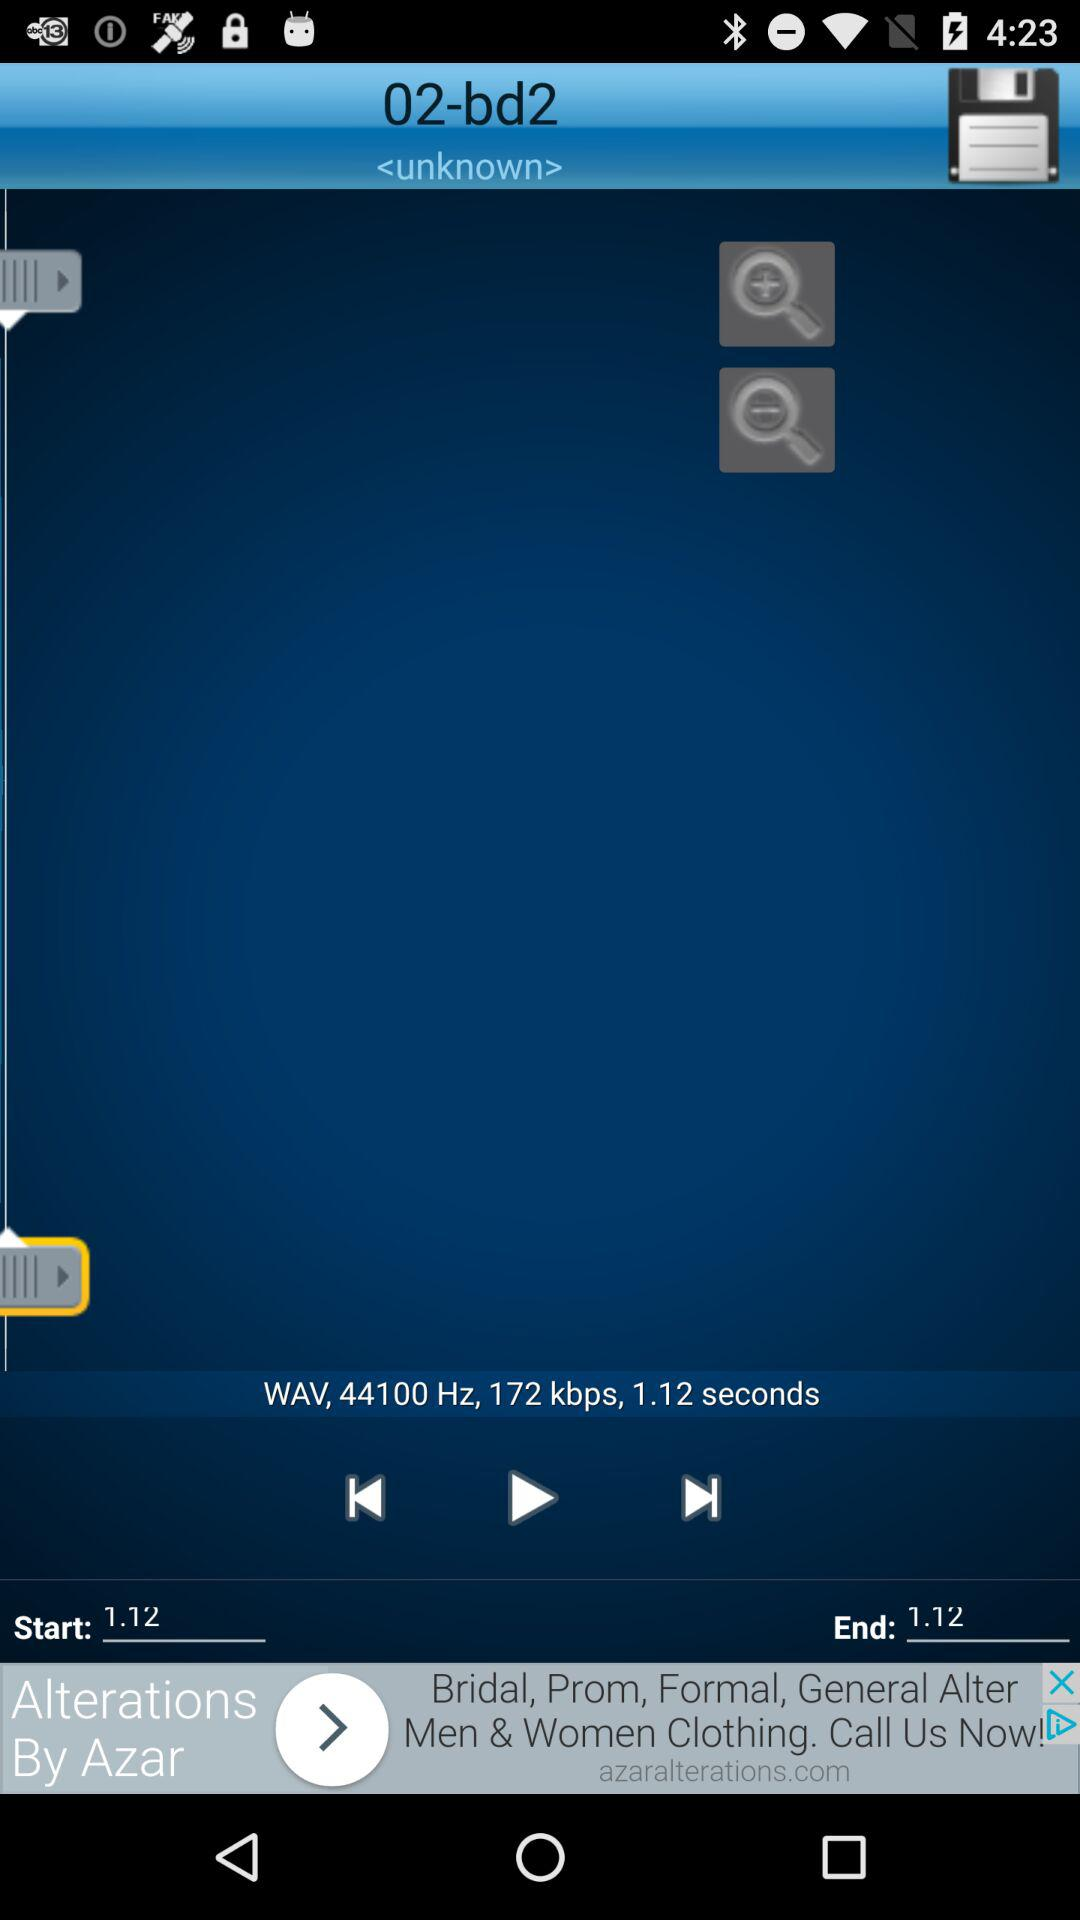How many seconds long is the audio file?
Answer the question using a single word or phrase. 1.12 